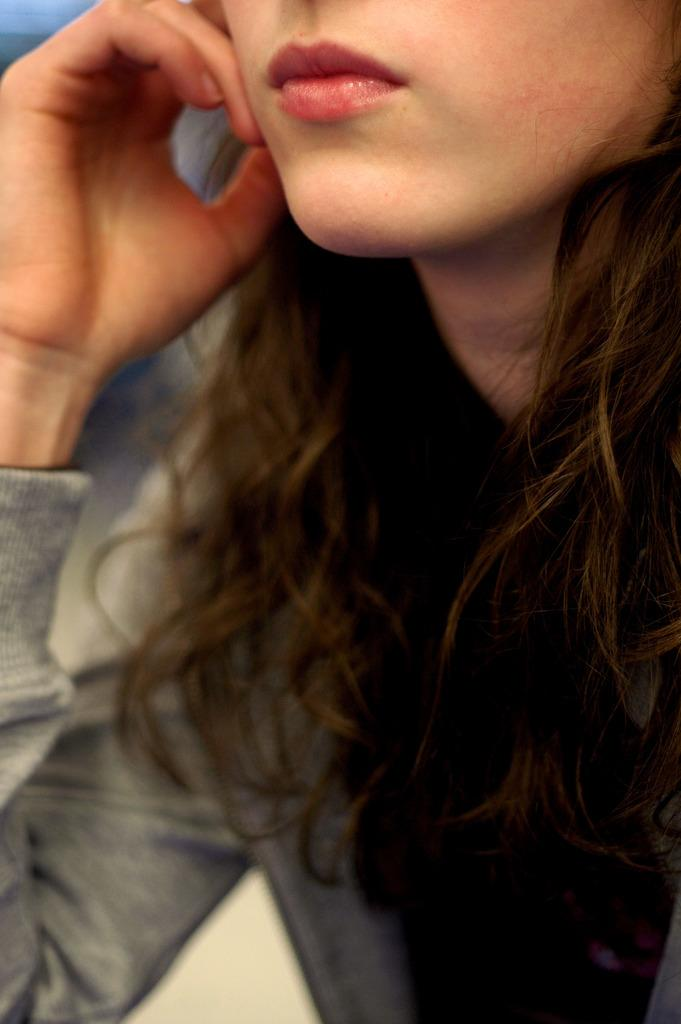Who is present in the image? There is a woman in the image. How many plates does the woman need in the image? There is no information about plates in the image, so it is impossible to determine how many the woman might need. 